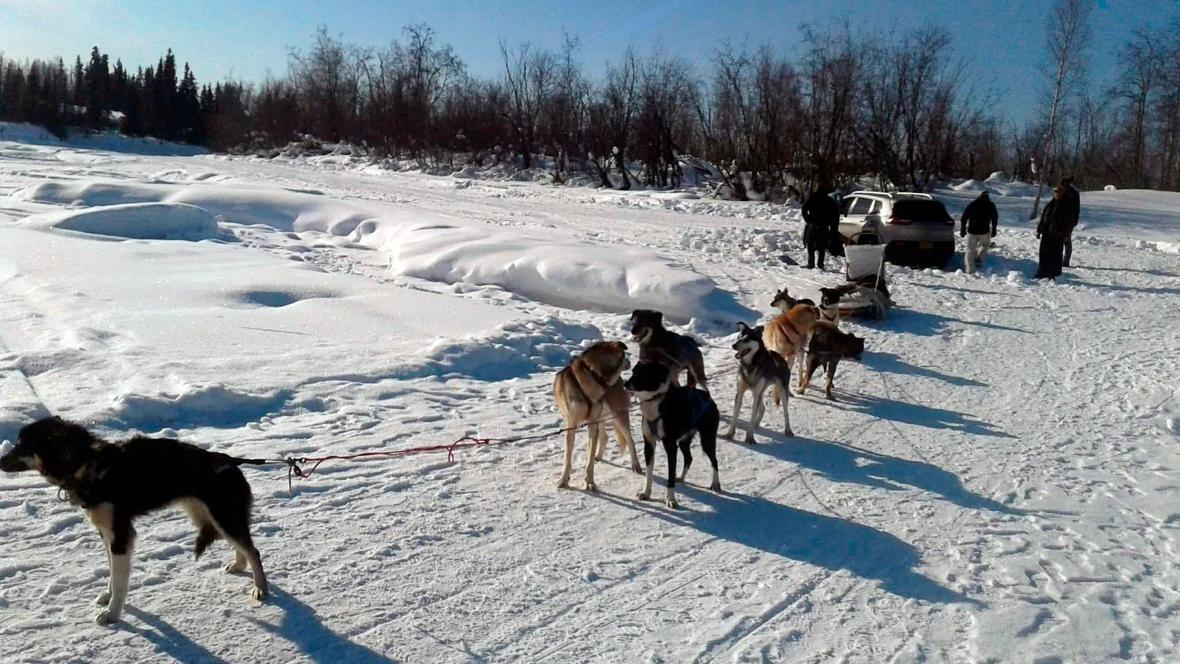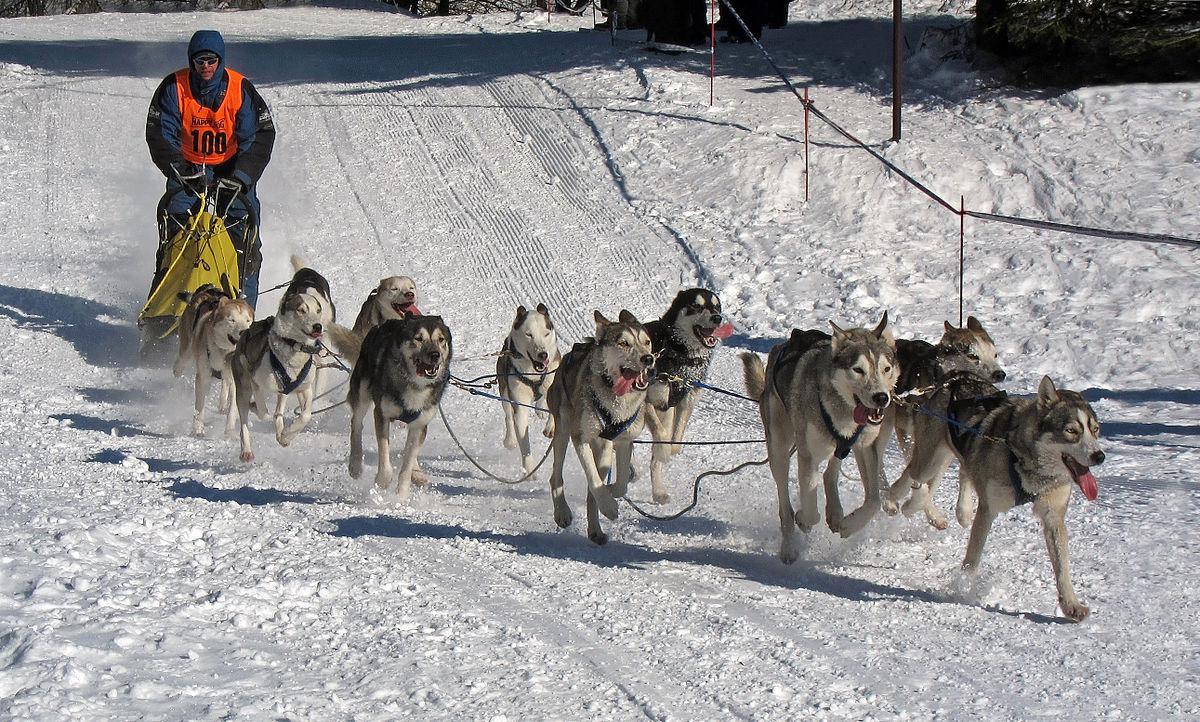The first image is the image on the left, the second image is the image on the right. For the images displayed, is the sentence "In the left image there are sled dogs up close pulling straight ahead towards the camera." factually correct? Answer yes or no. No. 